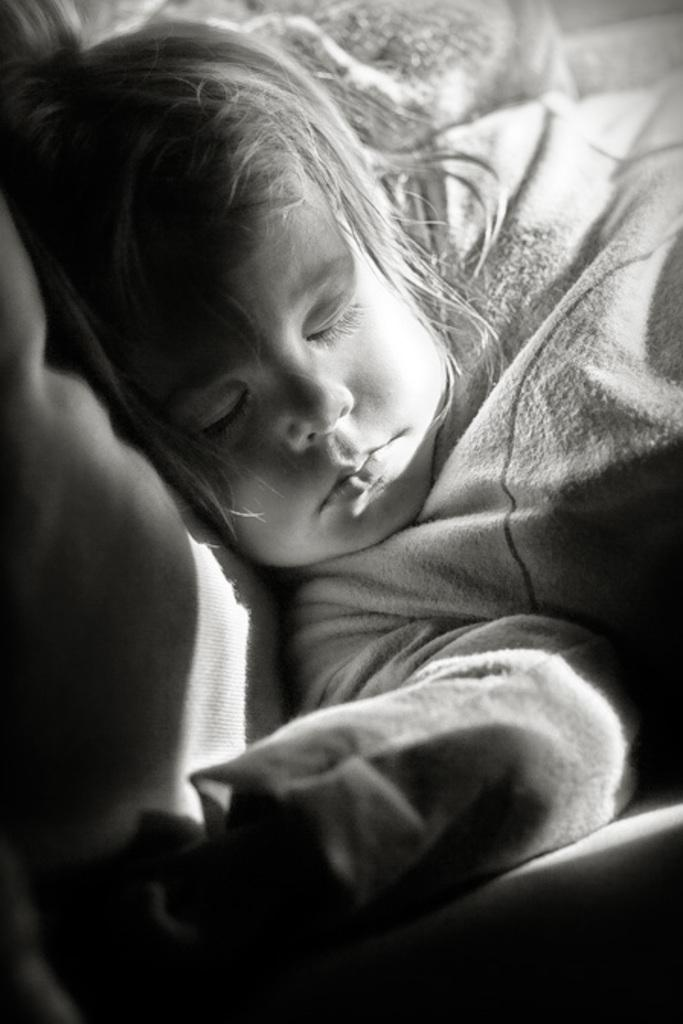What is the color scheme of the image? The image is black and white. What can be seen in the image? There is a child in the image. What is the child doing in the image? The child is sleeping. What type of farm equipment can be seen in the image? There is no farm equipment present in the image. How many spiders are crawling on the child in the image? There are no spiders visible in the image; the child is sleeping. 